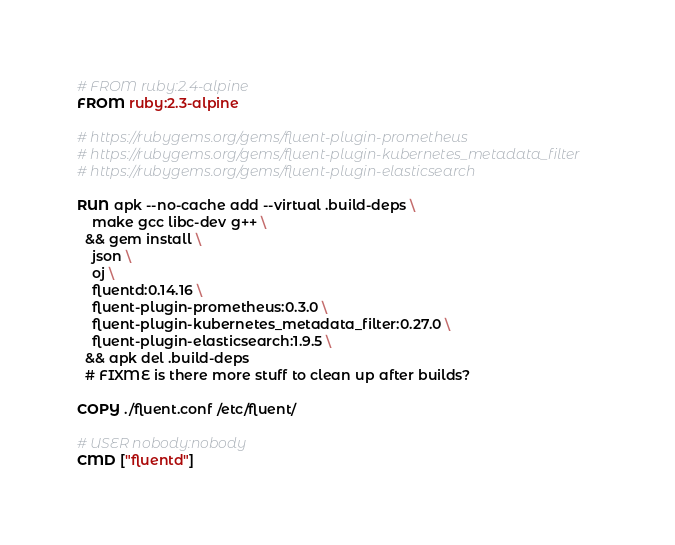<code> <loc_0><loc_0><loc_500><loc_500><_Dockerfile_># FROM ruby:2.4-alpine
FROM ruby:2.3-alpine

# https://rubygems.org/gems/fluent-plugin-prometheus
# https://rubygems.org/gems/fluent-plugin-kubernetes_metadata_filter
# https://rubygems.org/gems/fluent-plugin-elasticsearch

RUN apk --no-cache add --virtual .build-deps \
    make gcc libc-dev g++ \
  && gem install \
    json \
    oj \
    fluentd:0.14.16 \
    fluent-plugin-prometheus:0.3.0 \
    fluent-plugin-kubernetes_metadata_filter:0.27.0 \
    fluent-plugin-elasticsearch:1.9.5 \
  && apk del .build-deps
  # FIXME is there more stuff to clean up after builds?

COPY ./fluent.conf /etc/fluent/

# USER nobody:nobody
CMD ["fluentd"]
</code> 